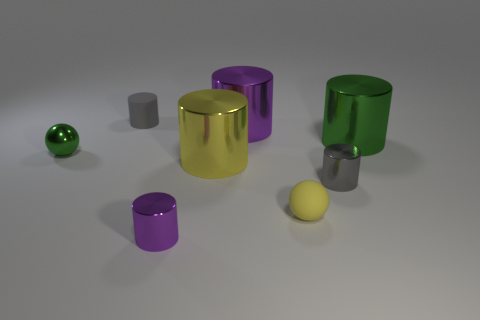Are there more gray metal objects than things?
Keep it short and to the point. No. Are there any big green shiny spheres?
Your response must be concise. No. The rubber object that is right of the big yellow thing that is to the left of the tiny gray metal cylinder is what shape?
Your answer should be very brief. Sphere. What number of things are red metal cubes or metal balls that are behind the yellow shiny thing?
Give a very brief answer. 1. There is a tiny ball that is left of the purple cylinder behind the small matte object that is to the right of the big purple object; what is its color?
Offer a terse response. Green. There is a yellow thing that is the same shape as the large green metal thing; what is its material?
Offer a terse response. Metal. What color is the tiny metal sphere?
Your answer should be very brief. Green. What number of shiny things are big cylinders or small red blocks?
Your answer should be very brief. 3. There is a cylinder on the left side of the purple thing that is in front of the big green shiny object; are there any big purple cylinders that are left of it?
Give a very brief answer. No. What size is the gray thing that is made of the same material as the yellow sphere?
Provide a succinct answer. Small. 